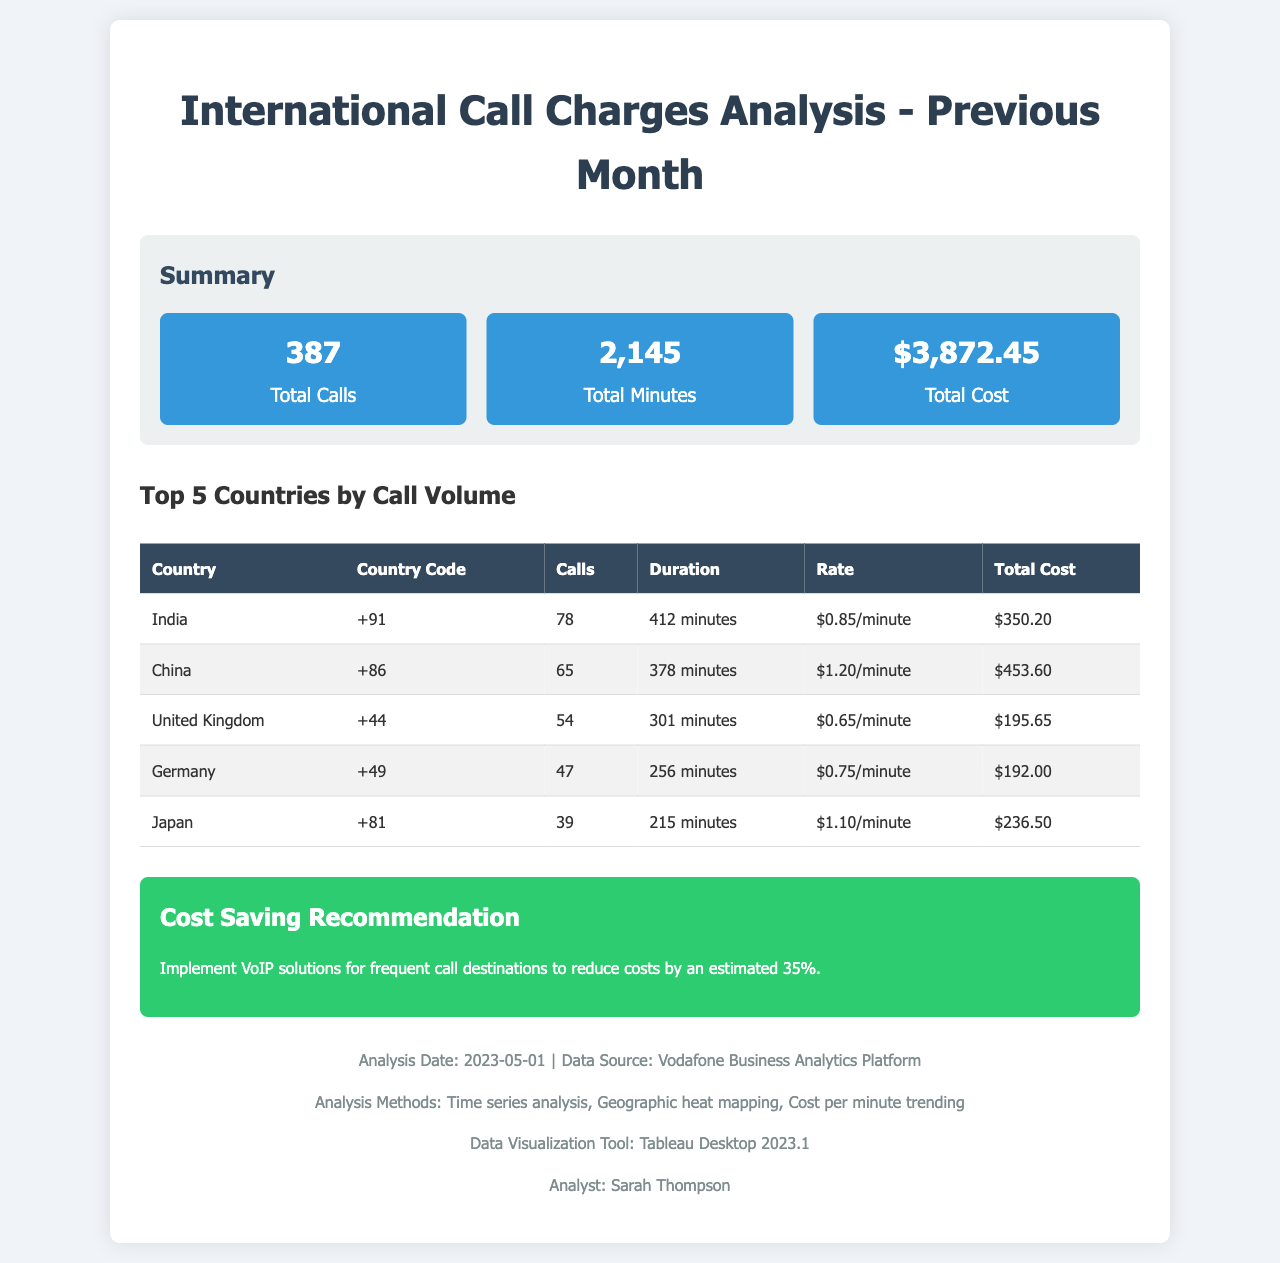What is the total number of calls? The total number of calls is reported in the summary section of the document as 387.
Answer: 387 What was the total duration of international calls? The total duration is found in the summary section, which states 2,145 minutes.
Answer: 2,145 minutes What is the country code for China? The country code for China can be found in the table under the "Country Code" column, which shows +86.
Answer: +86 Which country had the highest total cost? By comparing the total cost in the table, China has the highest total cost of $453.60.
Answer: China What is the rate per minute to call the United Kingdom? The rate per minute for the United Kingdom, indicated in the "Rate" column of the table, is $0.65/minute.
Answer: $0.65/minute What is the estimated cost saving by implementing VoIP? The document states that implementing VoIP is estimated to reduce costs by 35%.
Answer: 35% How many calls were made to Germany? The table indicates that there were 47 calls made to Germany.
Answer: 47 What was the total cost of calls to India? The total cost of calls to India, as shown in the table, is $350.20.
Answer: $350.20 What is the title of the document? The title is presented at the top of the document as "International Call Charges Analysis - Previous Month."
Answer: International Call Charges Analysis - Previous Month 